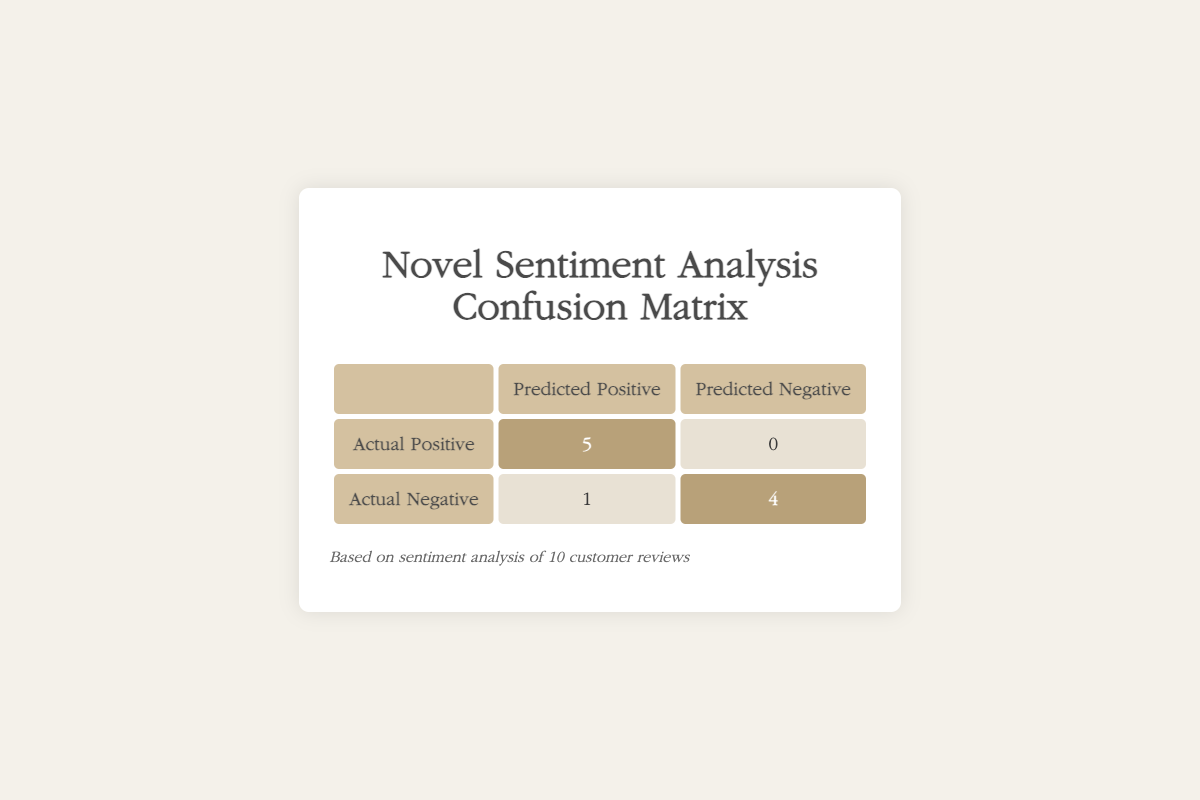What is the total number of positive sentiment predictions? To find the total number of positive sentiment predictions, we refer to the first row of the table under "Predicted Positive," which contains the value 5, and the second row under the same column, which has the value 1. Adding these gives us 5 + 1 = 6.
Answer: 6 How many reviews were actually negative? We look at the second row titled "Actual Negative." The values in this row indicate the number of reviews that were actually negative: we see a total of 5 (1 predicted positive and 4 predicted negative), so the answer is 5.
Answer: 5 Is there a review that was incorrectly classified as positive? In looking at the table, we note that under "Actual Negative" and "Predicted Positive," there is 1 instance. This indicates there is indeed one review that was incorrectly predicted as positive despite being negative.
Answer: Yes What is the accuracy of the sentiment prediction model? To calculate accuracy, we use the formula: (correct predictions) / (total predictions). The correct predictions are 5 (actual positive predicted positive) + 4 (actual negative predicted negative) = 9. The total predictions is 10. Thus, the accuracy is 9/10, which simplifies to 0.9 or 90%.
Answer: 90% How many total reviews were analyzed? We can find the total reviews by assessing all rows in the confusion matrix. The sum of all entries is 5 (actual positive) + 0 (actual positive predicted negative) + 1 (actual negative predicted positive) + 4 (actual negative predicted negative), totaling 10 reviews.
Answer: 10 What percentage of the reviews were correctly classified? The percentage of correctly classified reviews can be derived from the correct predictions, which is 9, and dividing that by the total number of reviews, which is 10, then multiplying by 100. This gives (9/10) * 100 = 90%.
Answer: 90% 